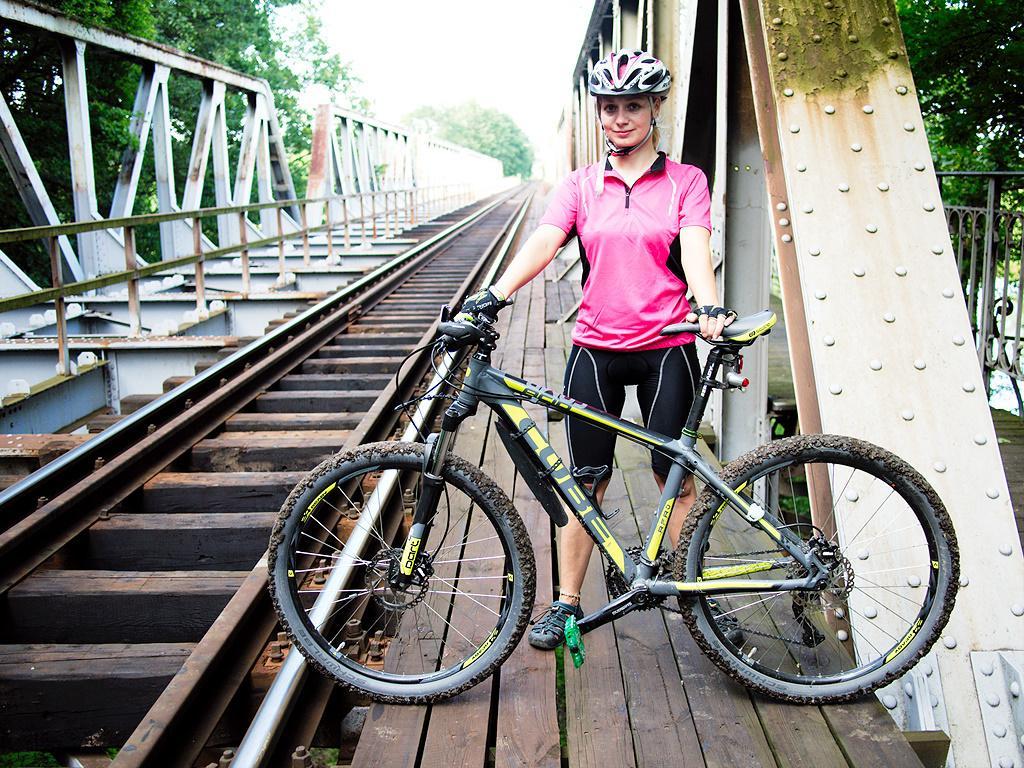How would you summarize this image in a sentence or two? There is a woman standing and holding a bicycle and wore helmet. We can see track,fence and this is bridge. In the background we can see trees. 